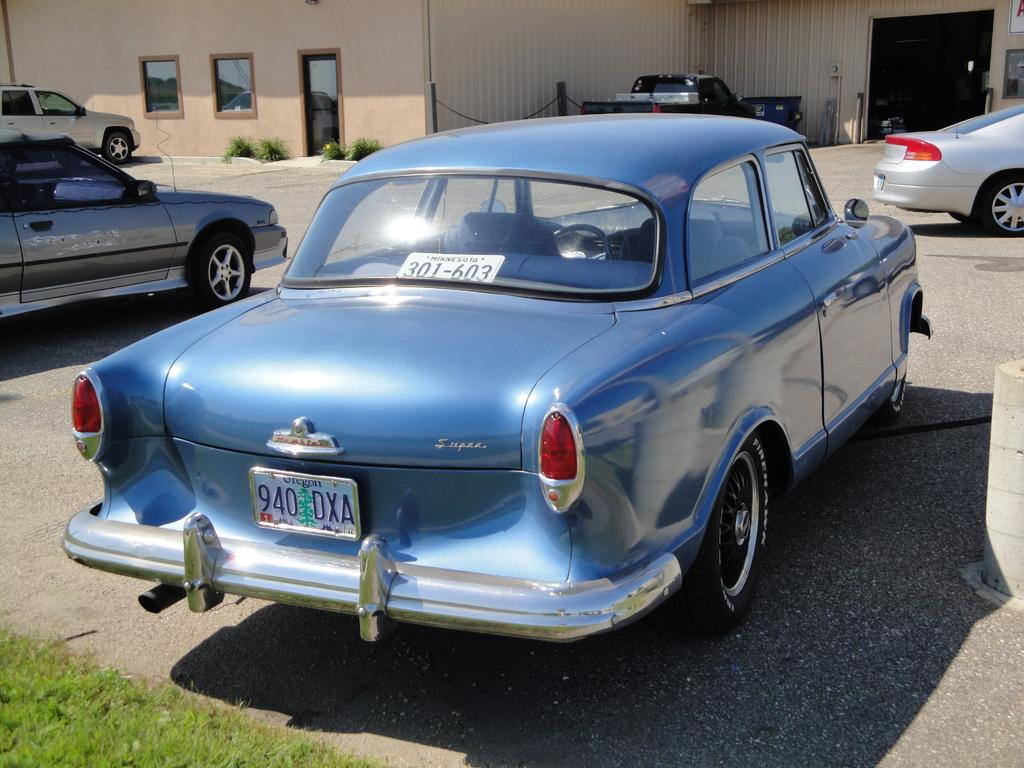What can be seen running through the image? There is a path in the image. How many cars are on the path? There are 5 cars on the path. What type of structure is present in the image? There is a building in the image. What other natural elements can be seen in the image? There are plants and green grass in the image. How would you describe the lighting in the image? The image appears to be dark. What type of love is being expressed by the minister in the image? There is no minister or expression of love present in the image. How many letters are visible in the image? There is no mention of letters in the provided facts, so we cannot determine if any are present in the image. 